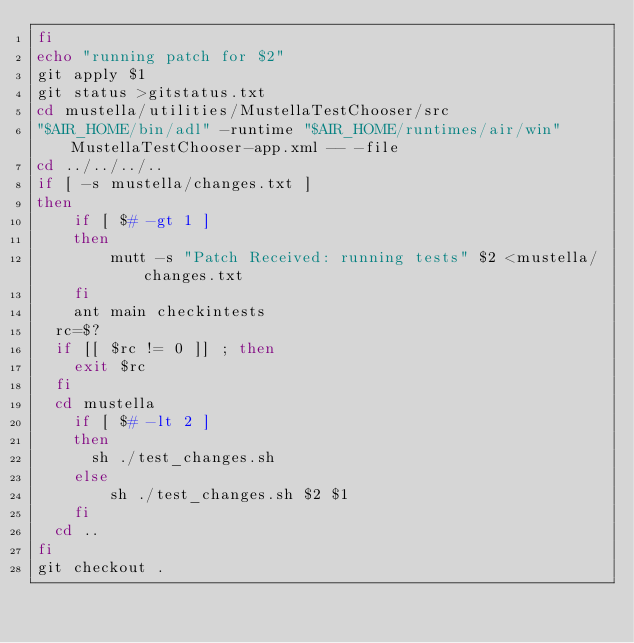Convert code to text. <code><loc_0><loc_0><loc_500><loc_500><_Bash_>fi
echo "running patch for $2"
git apply $1
git status >gitstatus.txt
cd mustella/utilities/MustellaTestChooser/src
"$AIR_HOME/bin/adl" -runtime "$AIR_HOME/runtimes/air/win" MustellaTestChooser-app.xml -- -file
cd ../../../..
if [ -s mustella/changes.txt ]
then
    if [ $# -gt 1 ]
    then
        mutt -s "Patch Received: running tests" $2 <mustella/changes.txt
    fi 
    ant main checkintests
	rc=$?
	if [[ $rc != 0 ]] ; then
		exit $rc
	fi
	cd mustella
    if [ $# -lt 2 ]
    then
	    sh ./test_changes.sh
    else
        sh ./test_changes.sh $2 $1
    fi
	cd ..
fi
git checkout .

</code> 